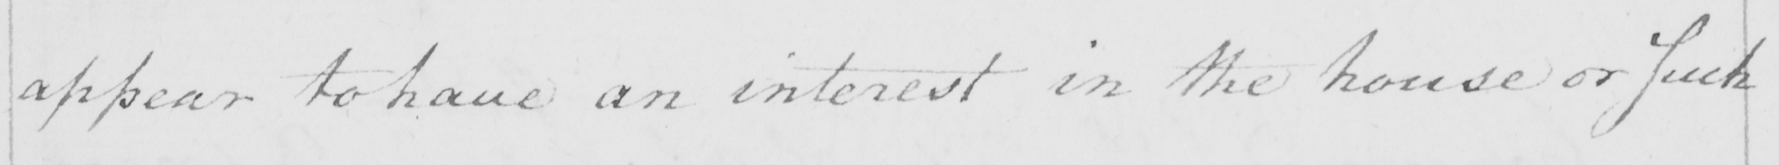What text is written in this handwritten line? appear to have an interest in the house or such 